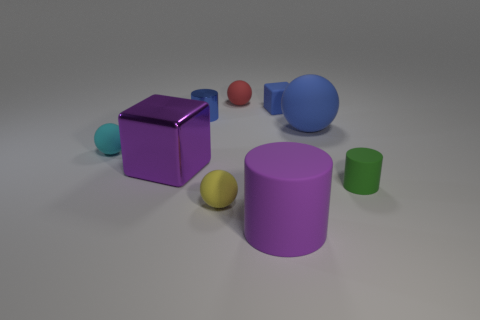Subtract all balls. How many objects are left? 5 Add 3 small yellow things. How many small yellow things exist? 4 Subtract 1 purple cylinders. How many objects are left? 8 Subtract all large cyan matte blocks. Subtract all big purple objects. How many objects are left? 7 Add 7 cyan spheres. How many cyan spheres are left? 8 